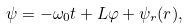<formula> <loc_0><loc_0><loc_500><loc_500>\psi = - \omega _ { 0 } t + L \varphi + \psi _ { r } ( r ) ,</formula> 